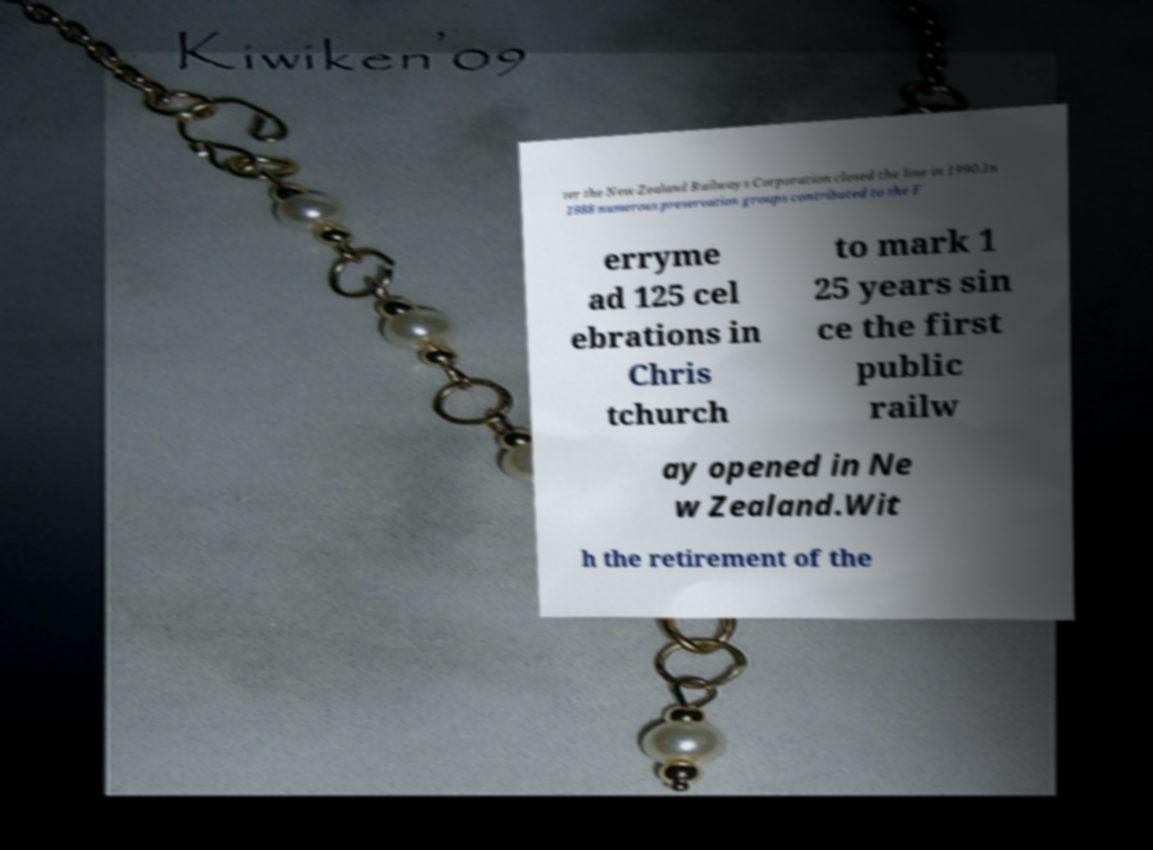I need the written content from this picture converted into text. Can you do that? ter the New Zealand Railways Corporation closed the line in 1990.In 1988 numerous preservation groups contributed to the F erryme ad 125 cel ebrations in Chris tchurch to mark 1 25 years sin ce the first public railw ay opened in Ne w Zealand.Wit h the retirement of the 